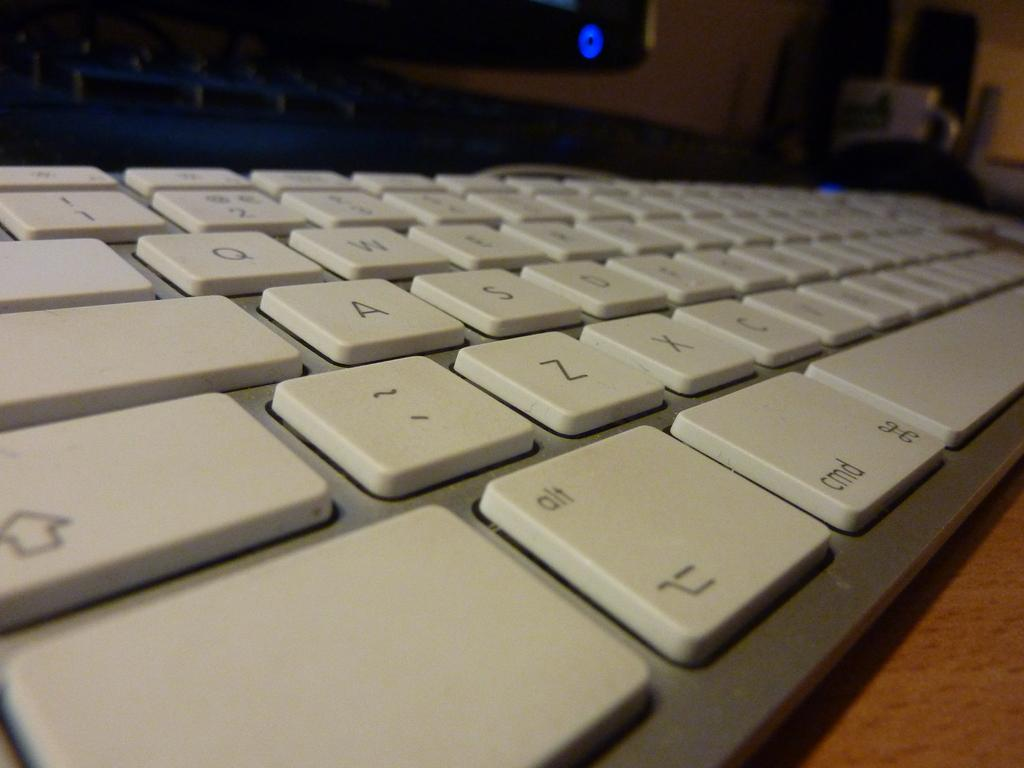Provide a one-sentence caption for the provided image. A keyboard with alt button next to the cmd button. 